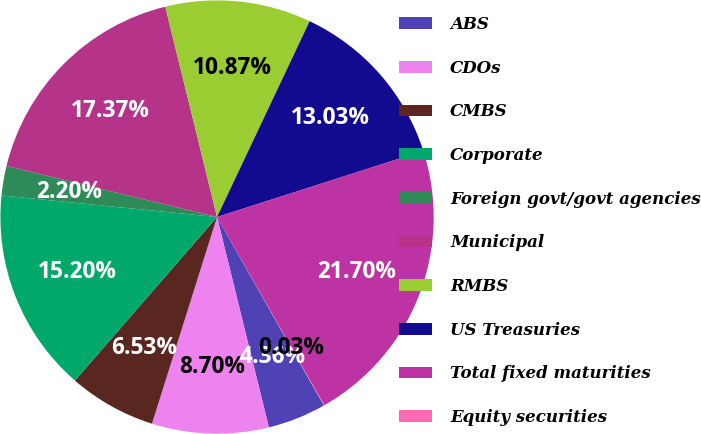Convert chart to OTSL. <chart><loc_0><loc_0><loc_500><loc_500><pie_chart><fcel>ABS<fcel>CDOs<fcel>CMBS<fcel>Corporate<fcel>Foreign govt/govt agencies<fcel>Municipal<fcel>RMBS<fcel>US Treasuries<fcel>Total fixed maturities<fcel>Equity securities<nl><fcel>4.36%<fcel>8.7%<fcel>6.53%<fcel>15.2%<fcel>2.2%<fcel>17.37%<fcel>10.87%<fcel>13.03%<fcel>21.7%<fcel>0.03%<nl></chart> 